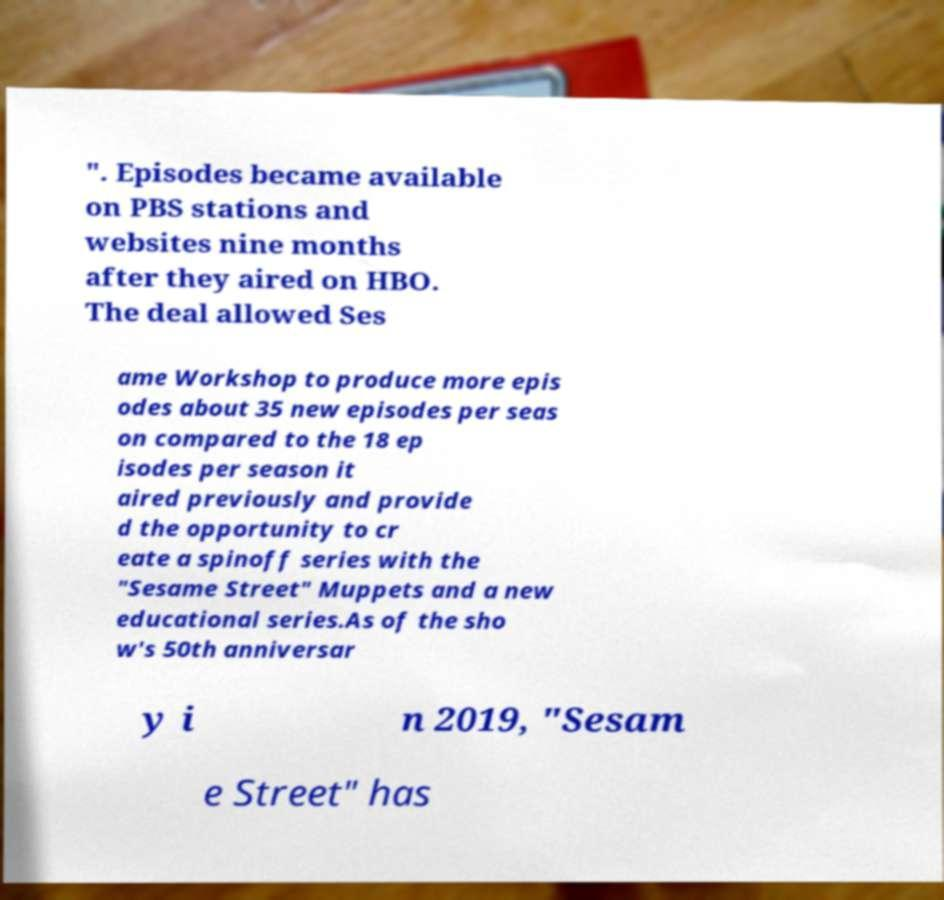Please read and relay the text visible in this image. What does it say? ". Episodes became available on PBS stations and websites nine months after they aired on HBO. The deal allowed Ses ame Workshop to produce more epis odes about 35 new episodes per seas on compared to the 18 ep isodes per season it aired previously and provide d the opportunity to cr eate a spinoff series with the "Sesame Street" Muppets and a new educational series.As of the sho w's 50th anniversar y i n 2019, "Sesam e Street" has 